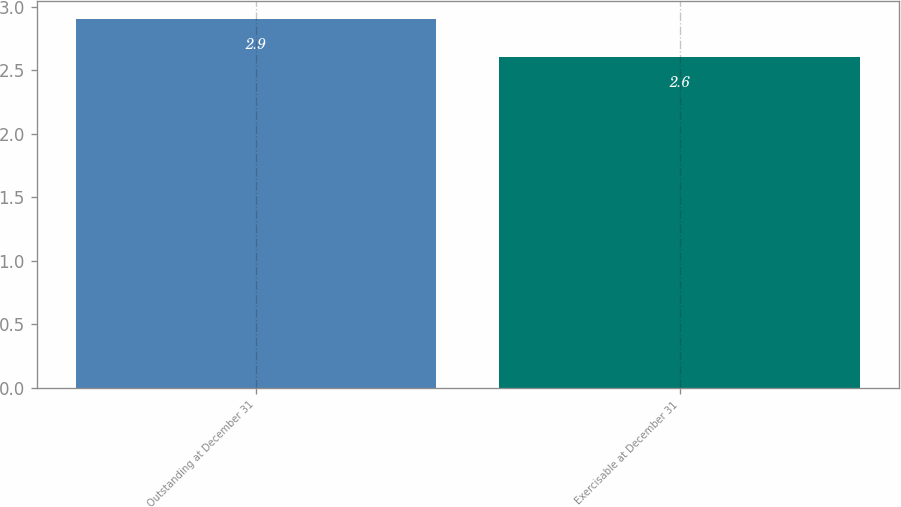Convert chart to OTSL. <chart><loc_0><loc_0><loc_500><loc_500><bar_chart><fcel>Outstanding at December 31<fcel>Exercisable at December 31<nl><fcel>2.9<fcel>2.6<nl></chart> 